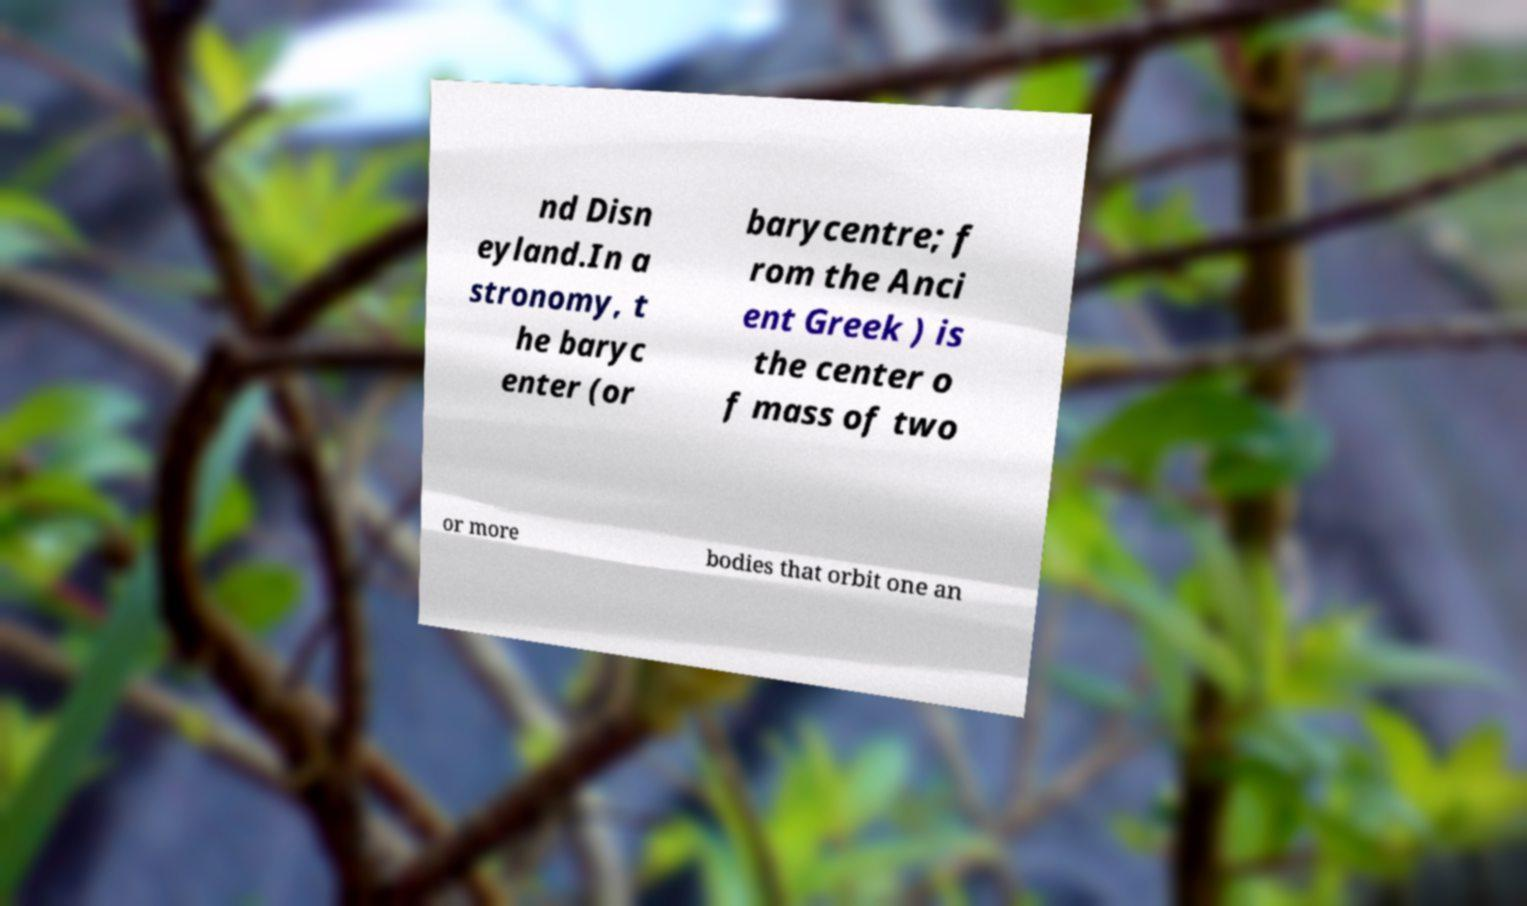I need the written content from this picture converted into text. Can you do that? nd Disn eyland.In a stronomy, t he baryc enter (or barycentre; f rom the Anci ent Greek ) is the center o f mass of two or more bodies that orbit one an 